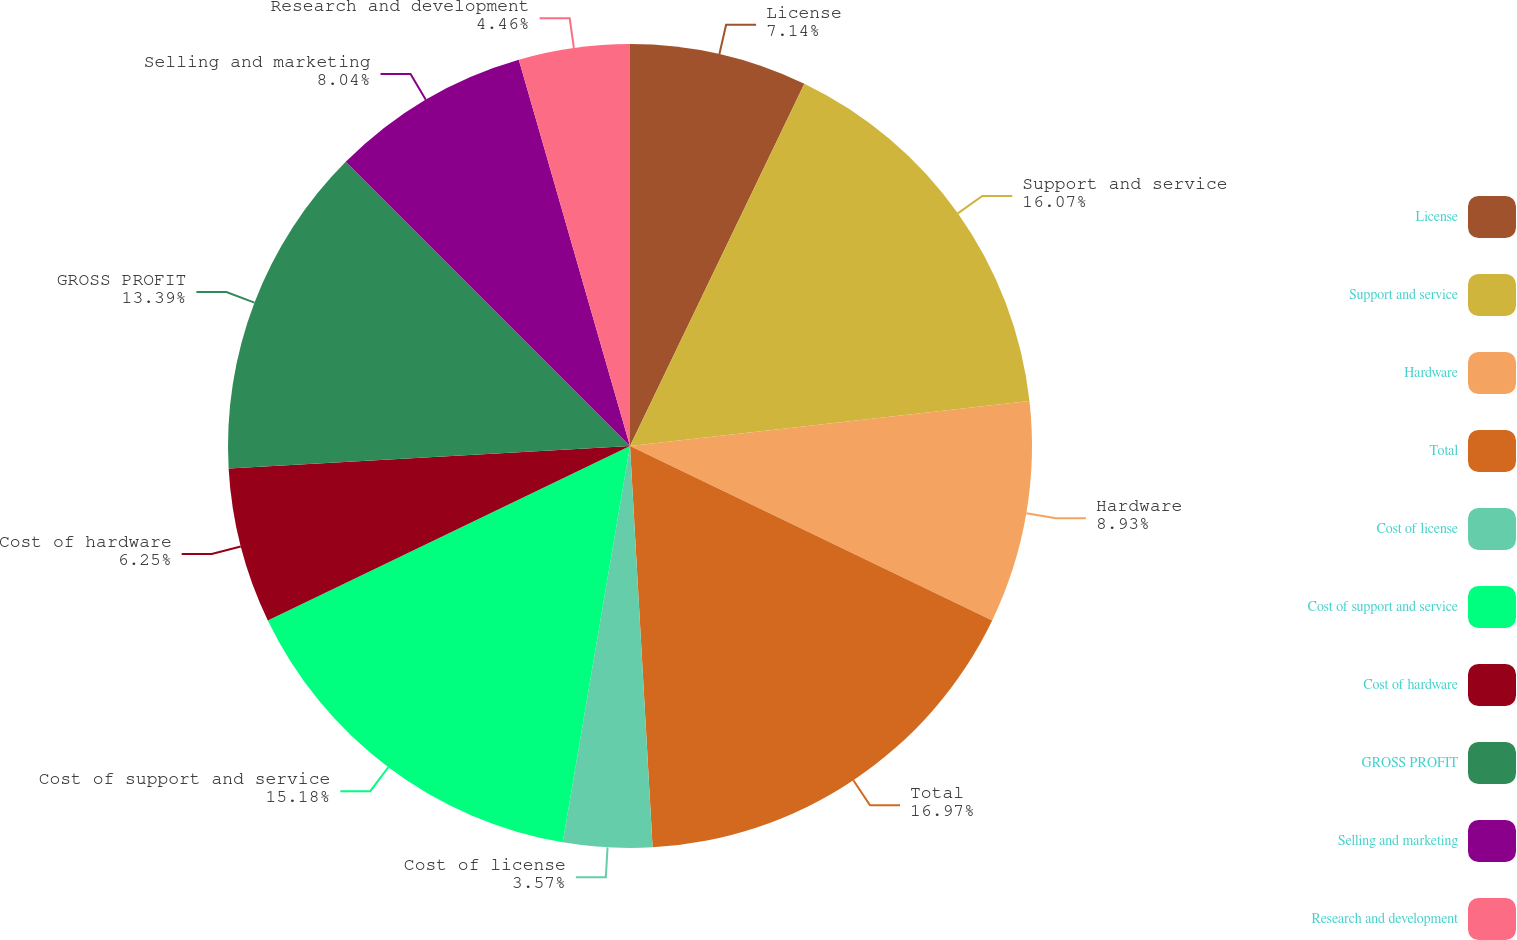Convert chart. <chart><loc_0><loc_0><loc_500><loc_500><pie_chart><fcel>License<fcel>Support and service<fcel>Hardware<fcel>Total<fcel>Cost of license<fcel>Cost of support and service<fcel>Cost of hardware<fcel>GROSS PROFIT<fcel>Selling and marketing<fcel>Research and development<nl><fcel>7.14%<fcel>16.07%<fcel>8.93%<fcel>16.96%<fcel>3.57%<fcel>15.18%<fcel>6.25%<fcel>13.39%<fcel>8.04%<fcel>4.46%<nl></chart> 